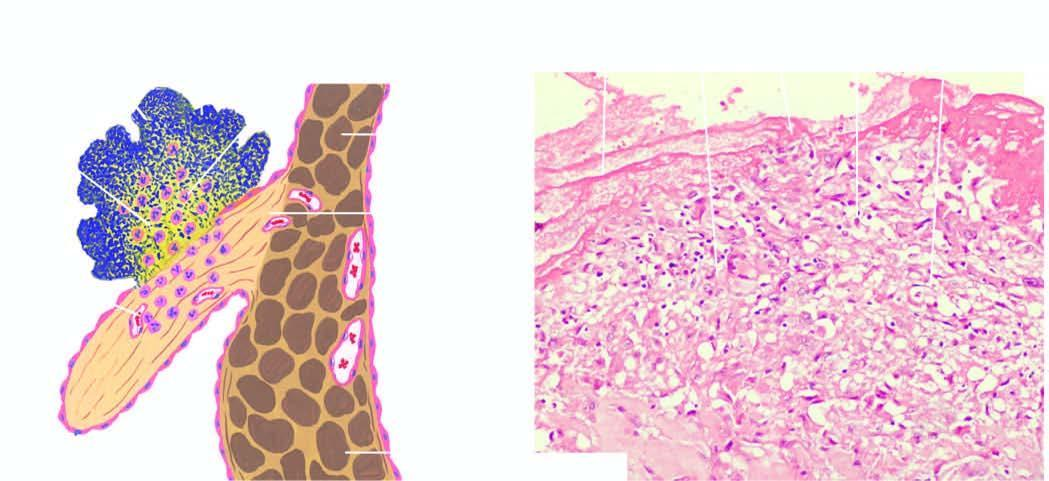what shows fibrin cap on luminal surface, layer of bacteria, and deeper zone of inflammatory cells, with prominence of neutrophils?
Answer the question using a single word or phrase. B 